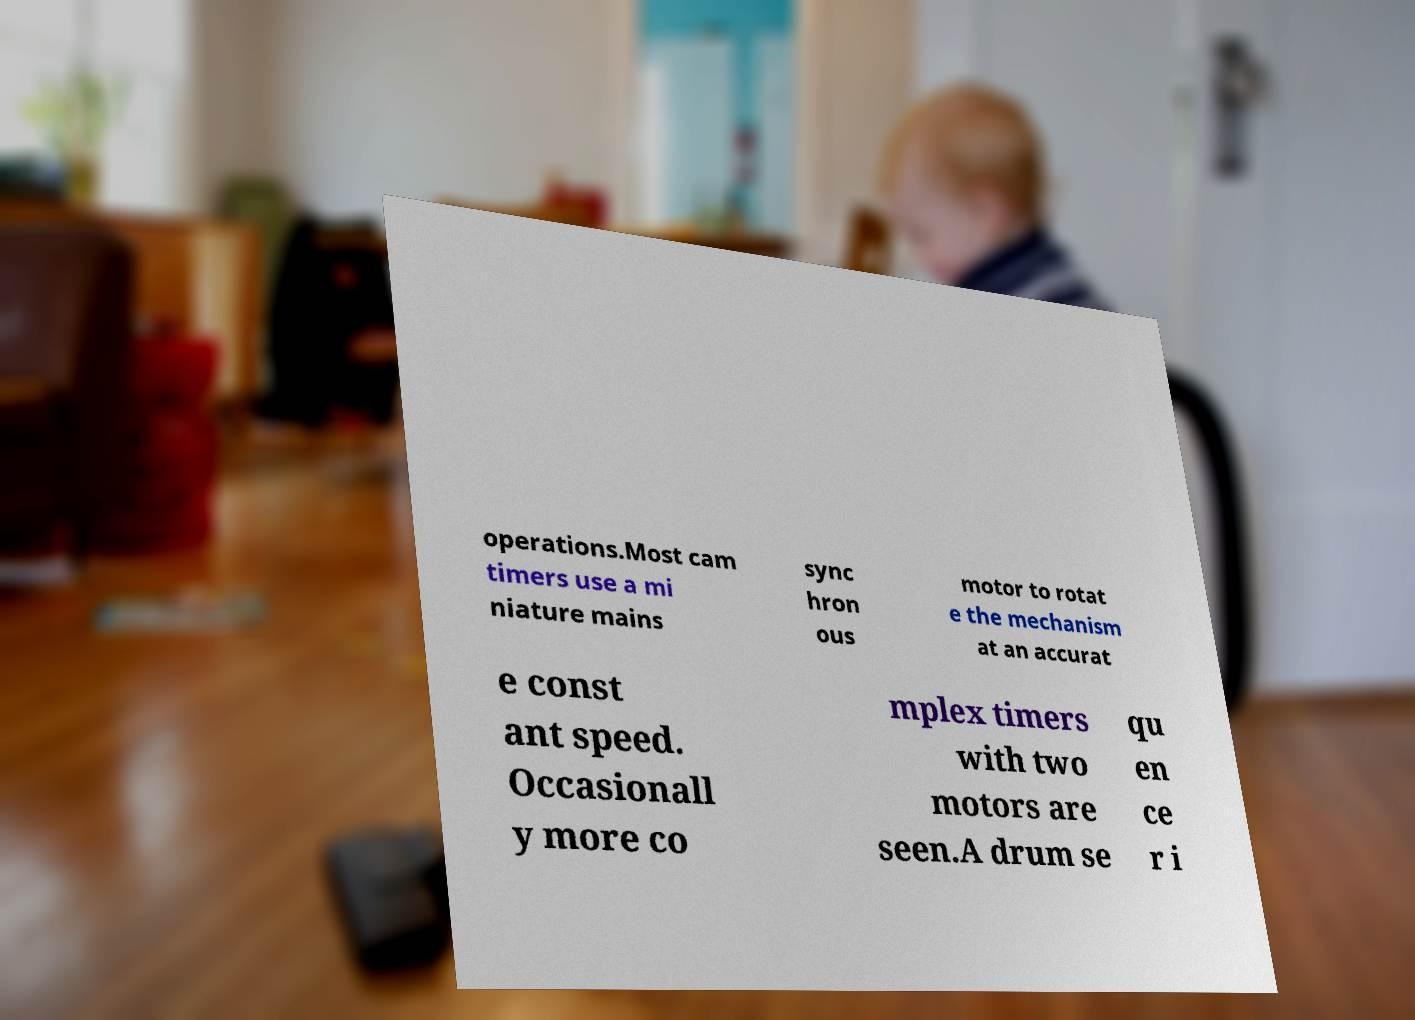Could you assist in decoding the text presented in this image and type it out clearly? operations.Most cam timers use a mi niature mains sync hron ous motor to rotat e the mechanism at an accurat e const ant speed. Occasionall y more co mplex timers with two motors are seen.A drum se qu en ce r i 